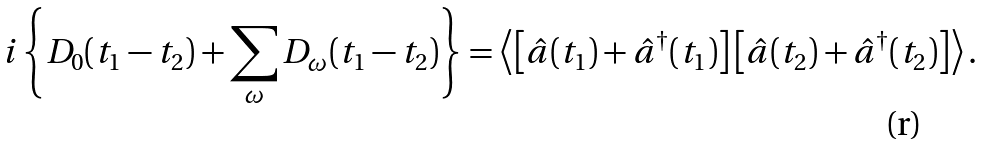<formula> <loc_0><loc_0><loc_500><loc_500>i \left \{ D _ { 0 } ( t _ { 1 } - t _ { 2 } ) + \sum _ { \omega } D _ { \omega } ( t _ { 1 } - t _ { 2 } ) \right \} = \left \langle \left [ \hat { a } ( t _ { 1 } ) + \hat { a } ^ { \dagger } ( t _ { 1 } ) \right ] \left [ \hat { a } ( t _ { 2 } ) + \hat { a } ^ { \dagger } ( t _ { 2 } ) \right ] \right \rangle .</formula> 